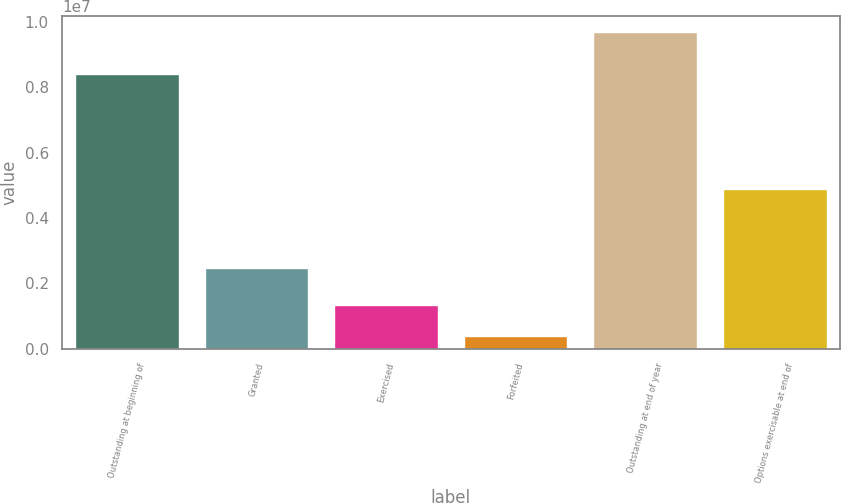Convert chart to OTSL. <chart><loc_0><loc_0><loc_500><loc_500><bar_chart><fcel>Outstanding at beginning of<fcel>Granted<fcel>Exercised<fcel>Forfeited<fcel>Outstanding at end of year<fcel>Options exercisable at end of<nl><fcel>8.40648e+06<fcel>2.46965e+06<fcel>1.3336e+06<fcel>405794<fcel>9.68382e+06<fcel>4.88448e+06<nl></chart> 